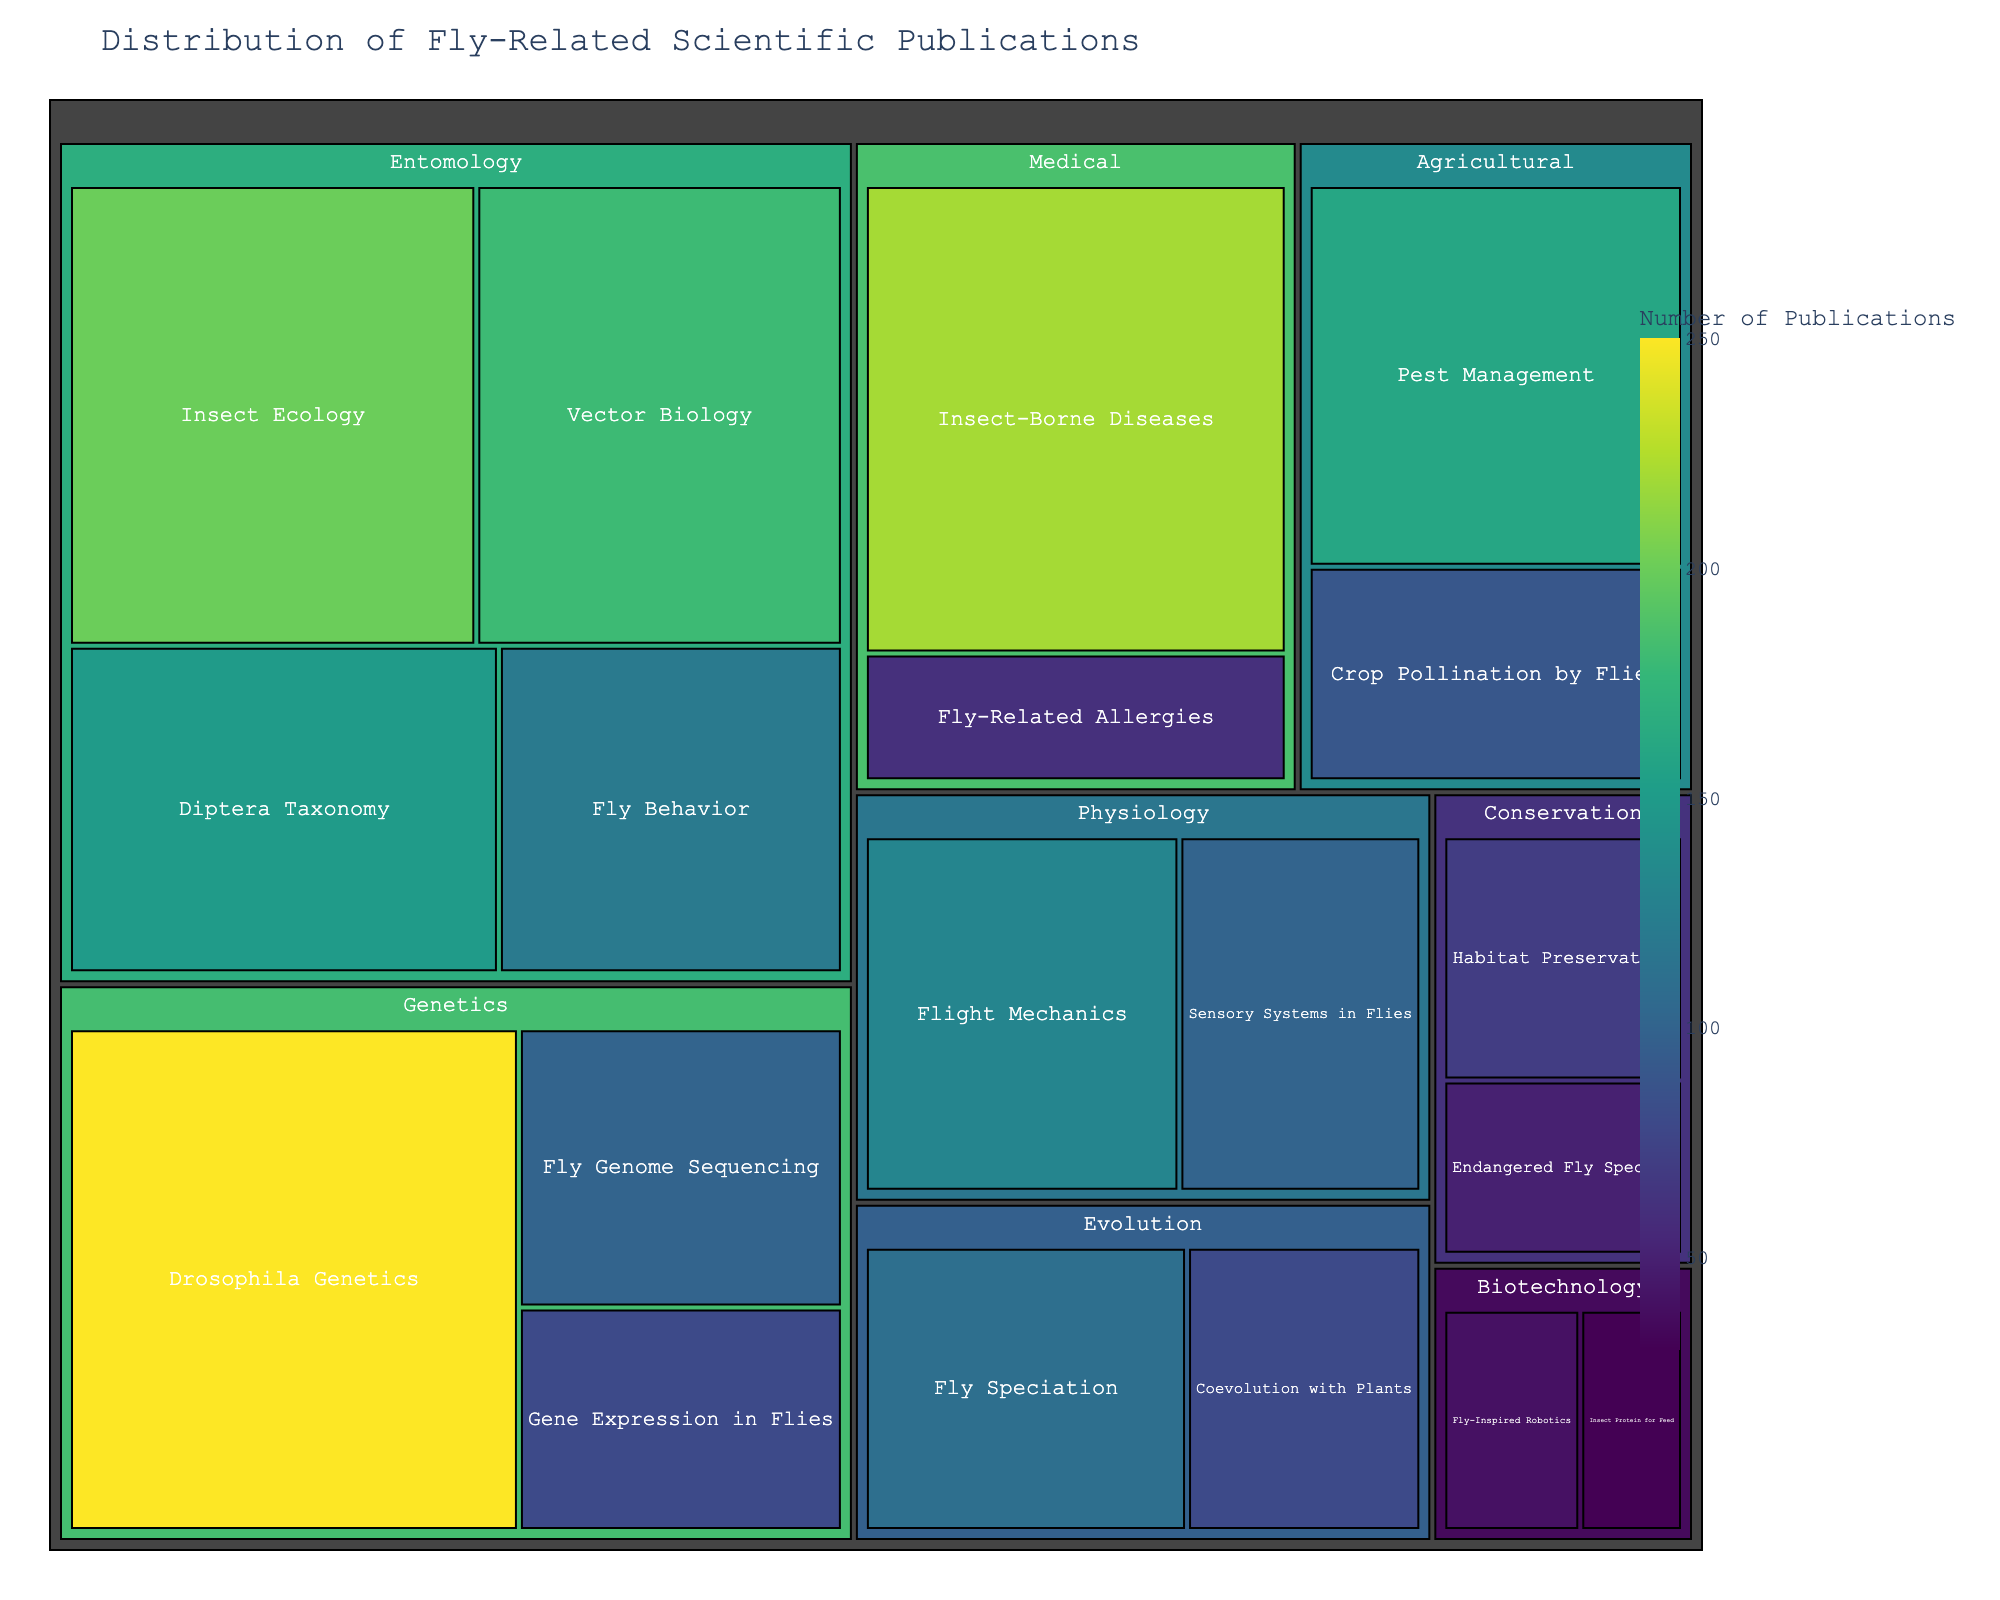What is the title of the treemap? The title is usually displayed prominently above the visual, indicating the main subject of the figure.
Answer: Distribution of Fly-Related Scientific Publications Which topic in the Genetics category has the highest number of publications? In the treemap, the topic with the largest box in the Genetics category will have the highest number of publications.
Answer: Drosophila Genetics How many publications are there in Entomology and Medical combined? Sum the total number of publications in the Entomology and Medical categories by adding their values. Entomology has 650 publications and Medical has 280. Combined, they have 650 + 280 = 930.
Answer: 930 Which category has the least number of publications overall? Compare the overall sizes of the categories displayed in the treemap. The category with the smallest area will have the least number of publications.
Answer: Biotechnology What is the difference between the number of publications in the topics of Fly Behavior and Fly Speciation? Subtract the number of publications in Fly Speciation from the number in Fly Behavior (120 - 110).
Answer: 10 Which categories contain more publications than Agricultural but less than Entomology? Compare the size of each category to identify those whose total publications lie between Agricultural (250) and Entomology (650). These are Genetics (430) and Medical (280).
Answer: Genetics and Medical Among Crop Pollination by Flies and Pest Management, which one has more publications and by how much? Compare the sizes of these topics within the Agricultural category. Subtract the value of Crop Pollination by Flies from Pest Management (160 - 90).
Answer: Pest Management by 70 How does the number of publications in Insect-Borne Diseases compare to that in Insect Ecology? Compare their sizes; Insect-Borne Diseases (220) versus Insect Ecology (200). The difference is 220 - 200 = 20.
Answer: Insect-Borne Diseases has 20 more What is the average number of publications across topics in the Conservation category? Add the publications in Conservation topics (50 + 70 = 120) and divide by the number of topics (2).
Answer: 60 Which topic within Physiology has more publications? Compare the sizes of the topics, Flight Mechanics (130) and Sensory Systems in Flies (100).
Answer: Flight Mechanics 